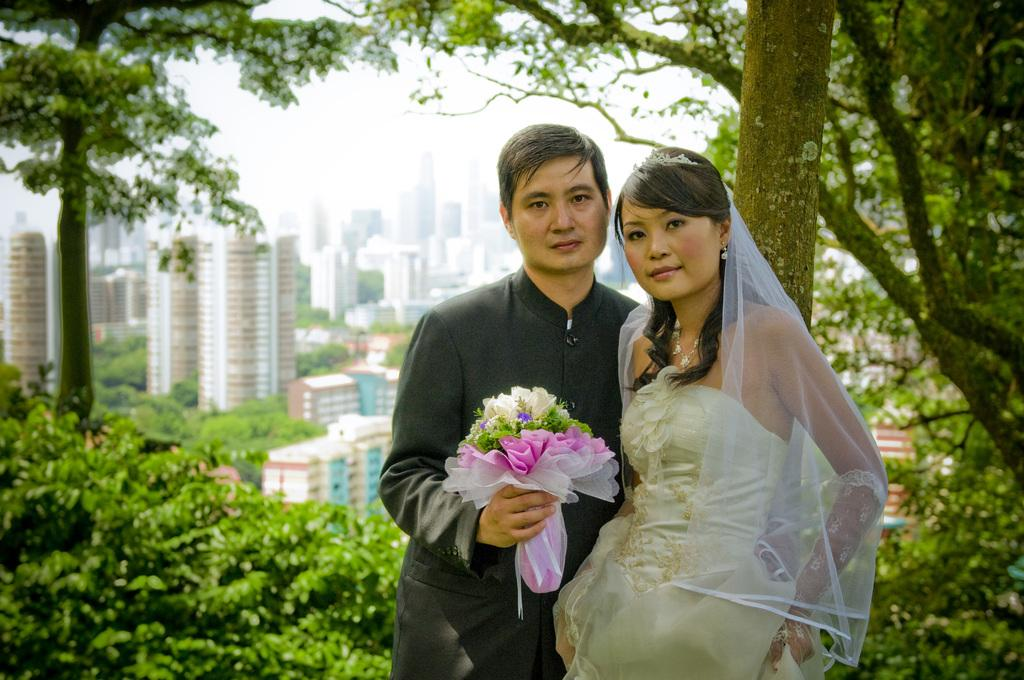Who can be seen in the image? There is a couple standing in the image. What can be seen in the background of the image? There are plants, trees, and buildings visible in the background of the image. What type of fog can be seen surrounding the couple in the image? There is no fog present in the image. 